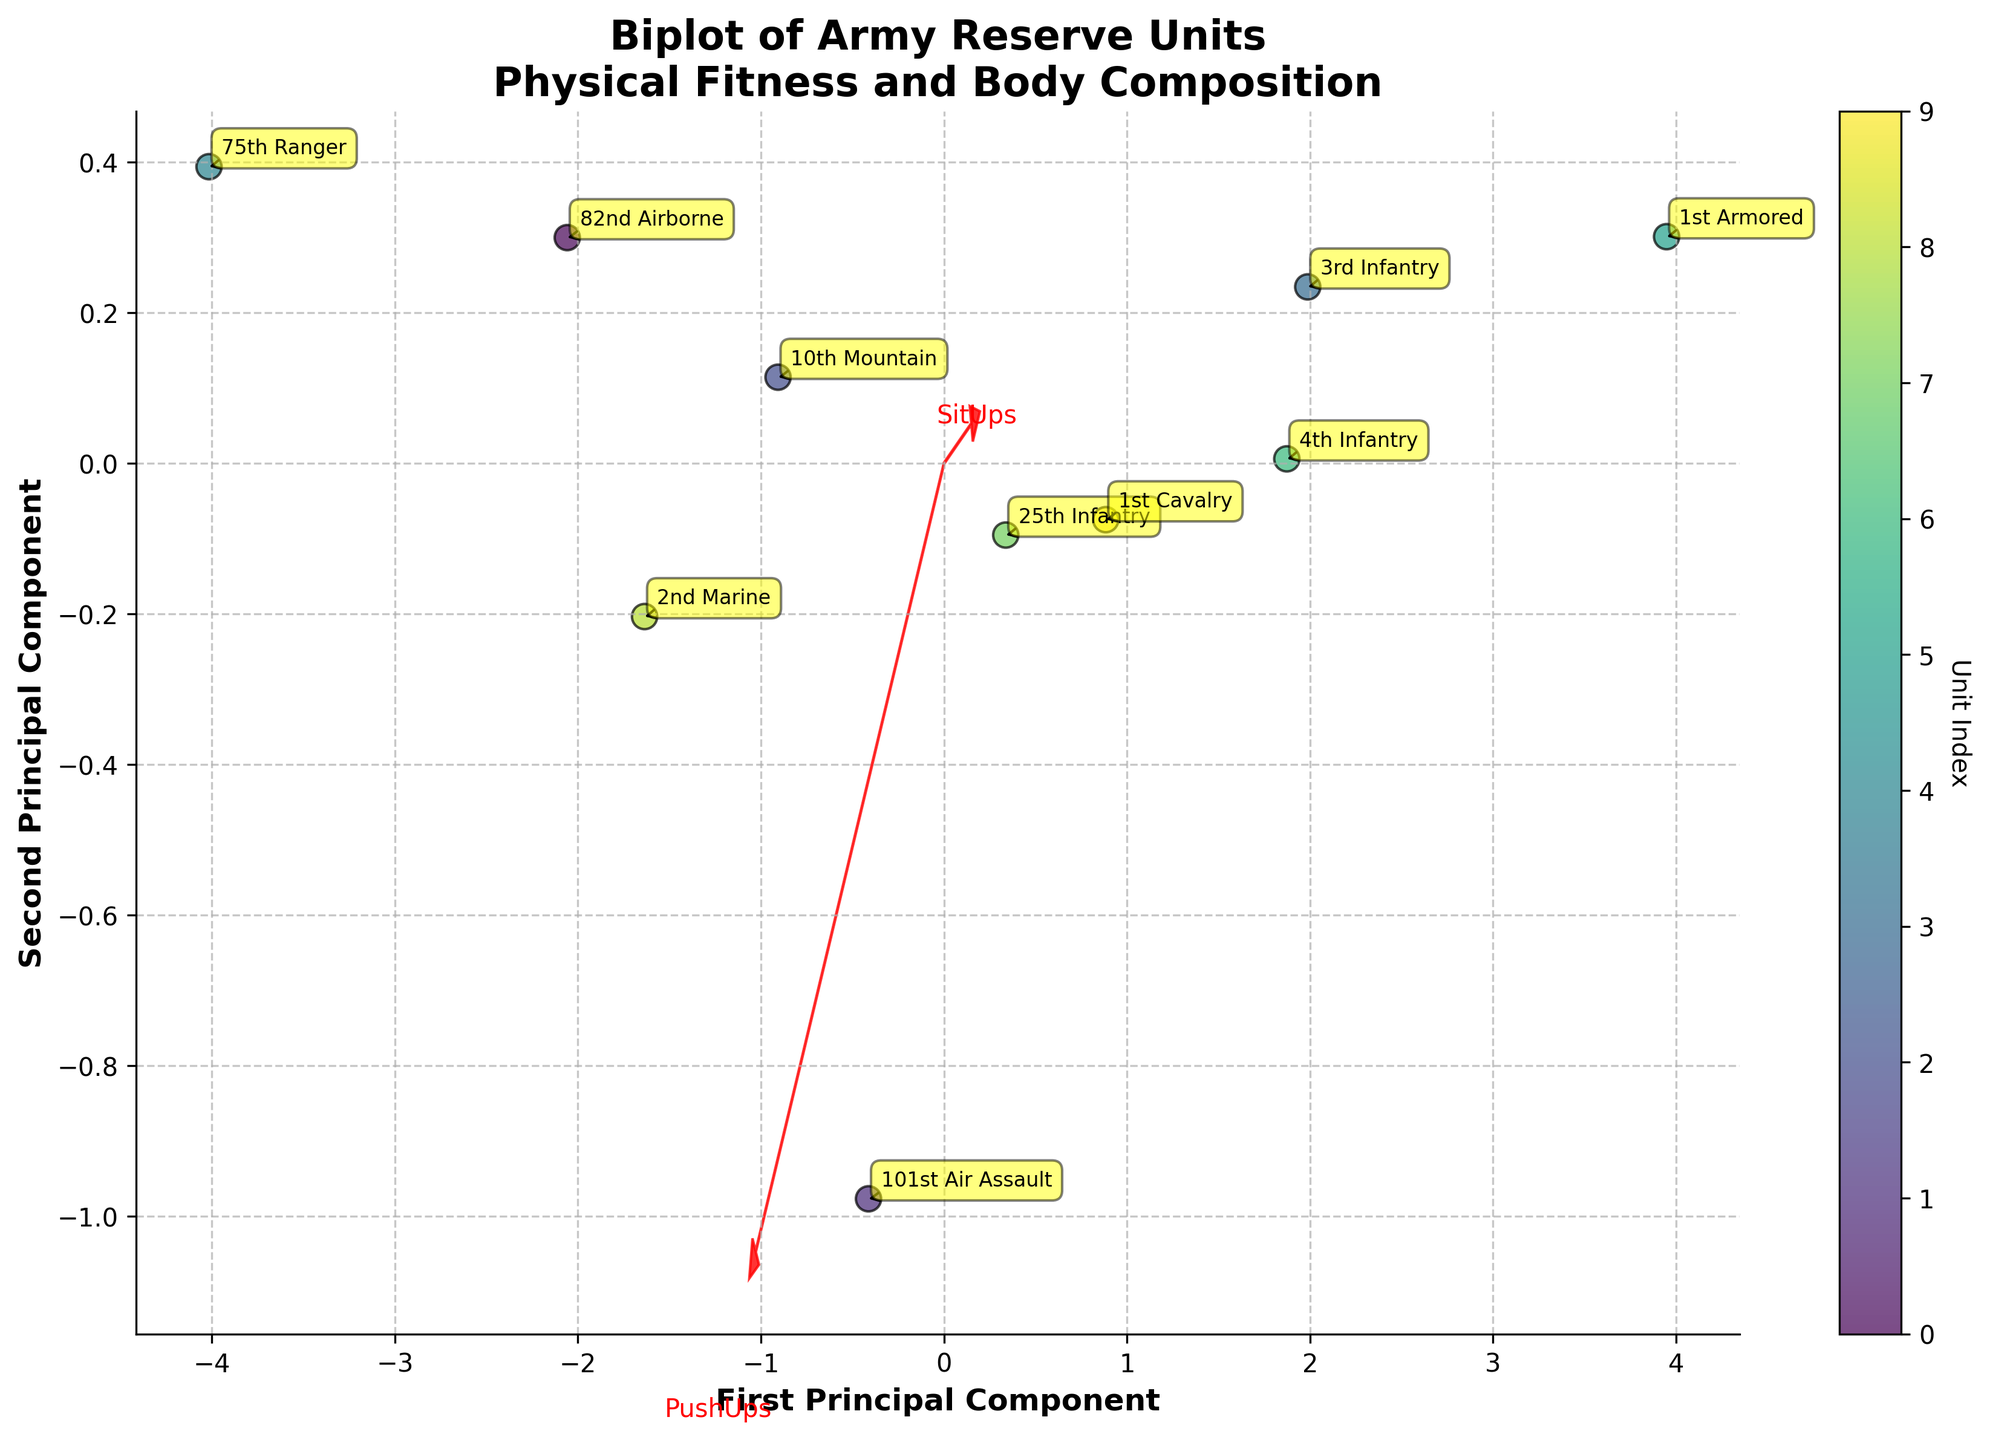What is the title of the biplot? The title can be seen at the top of the figure, usually in a larger and bold font compared to other text elements on the plot.
Answer: Biplot of Army Reserve Units Physical Fitness and Body Composition Which unit has the highest value on the First Principal Component? To determine this, look at the data points on the x-axis (First Principal Component) and identify which unit is furthest to the right.
Answer: 75th Ranger How many Army Reserve units are represented in the biplot? Count the number of labeled data points in the figure. Each label represents an Army Reserve unit.
Answer: 10 Which units are closest to each other in the biplot? Compare the distances between data points to see which pairs are nearest to each other. Look at the clustering of labels.
Answer: 10th Mountain and 25th Infantry What does an arrow in the biplot represent? Observing the plot, arrows typically represent the directions and magnitudes of the original variables in the reduced PCA space. Each arrow is labeled with a variable name.
Answer: Original variables Which unit has the lowest 2MileRun performance based on the biplot? Locate the arrow labeled "2MileRun" and see which unit's data point is furthest in the opposite direction of the arrow. This indicates a lower value for that performance measure.
Answer: 1st Armored What does the color of the data points represent in the biplot? There is a colorbar on the side of the plot that shows the gradient of colors correlated with unit index. Each color represents a unique unit.
Answer: Unit Index Do units with higher BodyFatPercentage tend to cluster together? Find the arrow labeled "BodyFatPercentage" and observe the distribution of data points along that direction. Assess whether units with higher values cluster on one side of the PCA space.
Answer: Yes Which variables have the largest influence on the First Principal Component? Identify which arrows are more aligned with the x-axis (First Principal Component) and have longer lengths, indicating a larger influence of those variables on the component.
Answer: PushUps, 2MileRun Based on the biplot, which unit is likely to have a balanced performance across different fitness measures? Search for a unit that is centrally located among the majority of arrows and close to the origin. This suggests it does not extremize particular measures.
Answer: 2nd Marine 